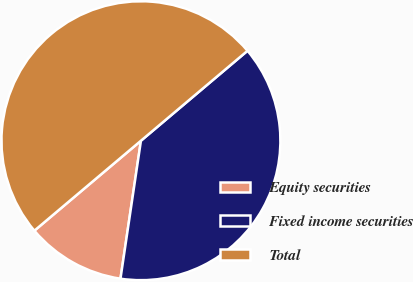<chart> <loc_0><loc_0><loc_500><loc_500><pie_chart><fcel>Equity securities<fcel>Fixed income securities<fcel>Total<nl><fcel>11.5%<fcel>38.5%<fcel>50.0%<nl></chart> 